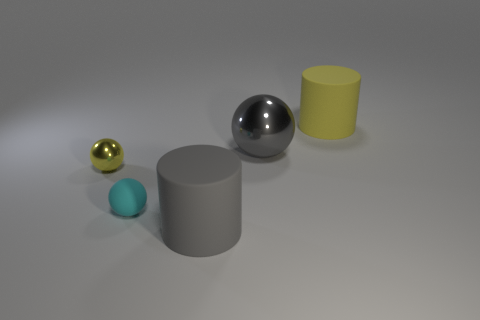Add 4 small shiny objects. How many objects exist? 9 Subtract all tiny spheres. How many spheres are left? 1 Subtract all cylinders. How many objects are left? 3 Add 1 cyan things. How many cyan things are left? 2 Add 5 tiny things. How many tiny things exist? 7 Subtract 1 gray balls. How many objects are left? 4 Subtract all small green shiny cubes. Subtract all large matte cylinders. How many objects are left? 3 